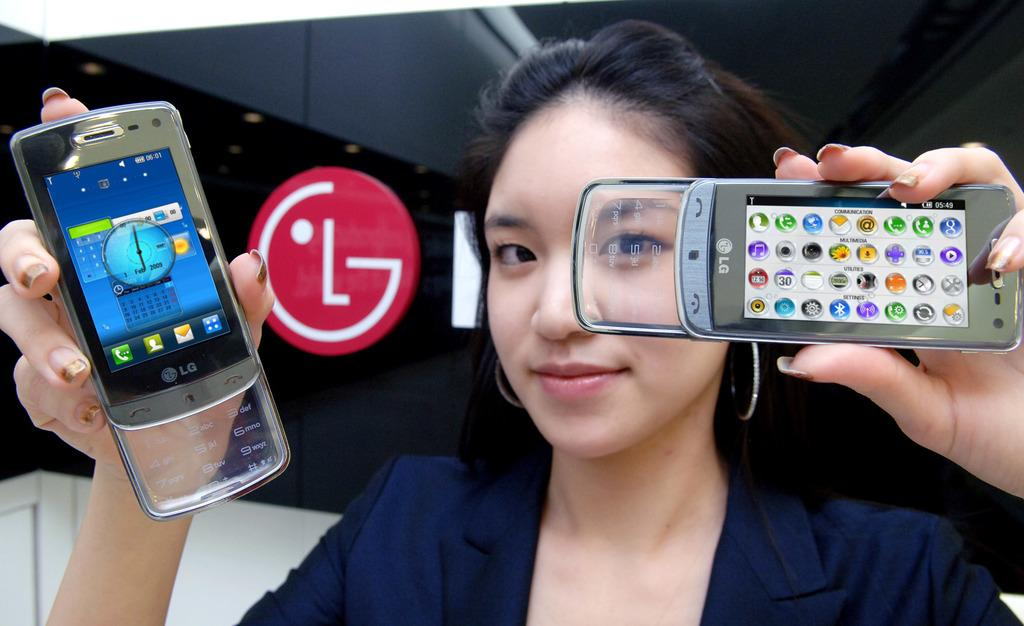What is the main subject of the image? The main subject of the image is a woman. What is the woman holding in each hand? The woman is holding a mobile phone in each hand. Can you hear the noise of the river flowing in the image? There is no river or any noise present in the image; it features a woman holding mobile phones. 